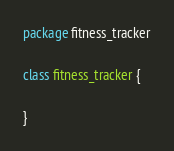Convert code to text. <code><loc_0><loc_0><loc_500><loc_500><_Scala_>package fitness_tracker

class fitness_tracker {

}
</code> 